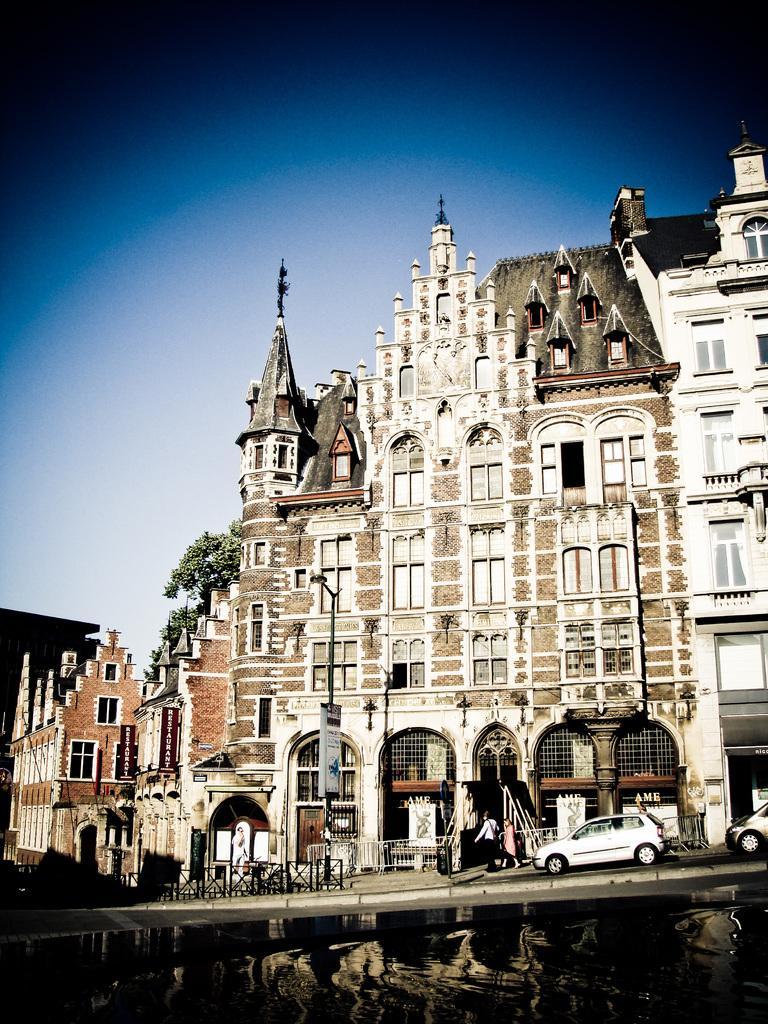Please provide a concise description of this image. This image is taken outdoors. At the top of the image there is the sky. At the bottom of the image there is a pond with water. In the middle of the image there is a bridge with a railing. There are a few buildings with walls, windows, doors and roofs. There are a few carvings and sculptures on the walls. In the background there is a tree. On the right side of the image two cars are moving on the bridge. There is a pole with a street light and there are a few boards. 